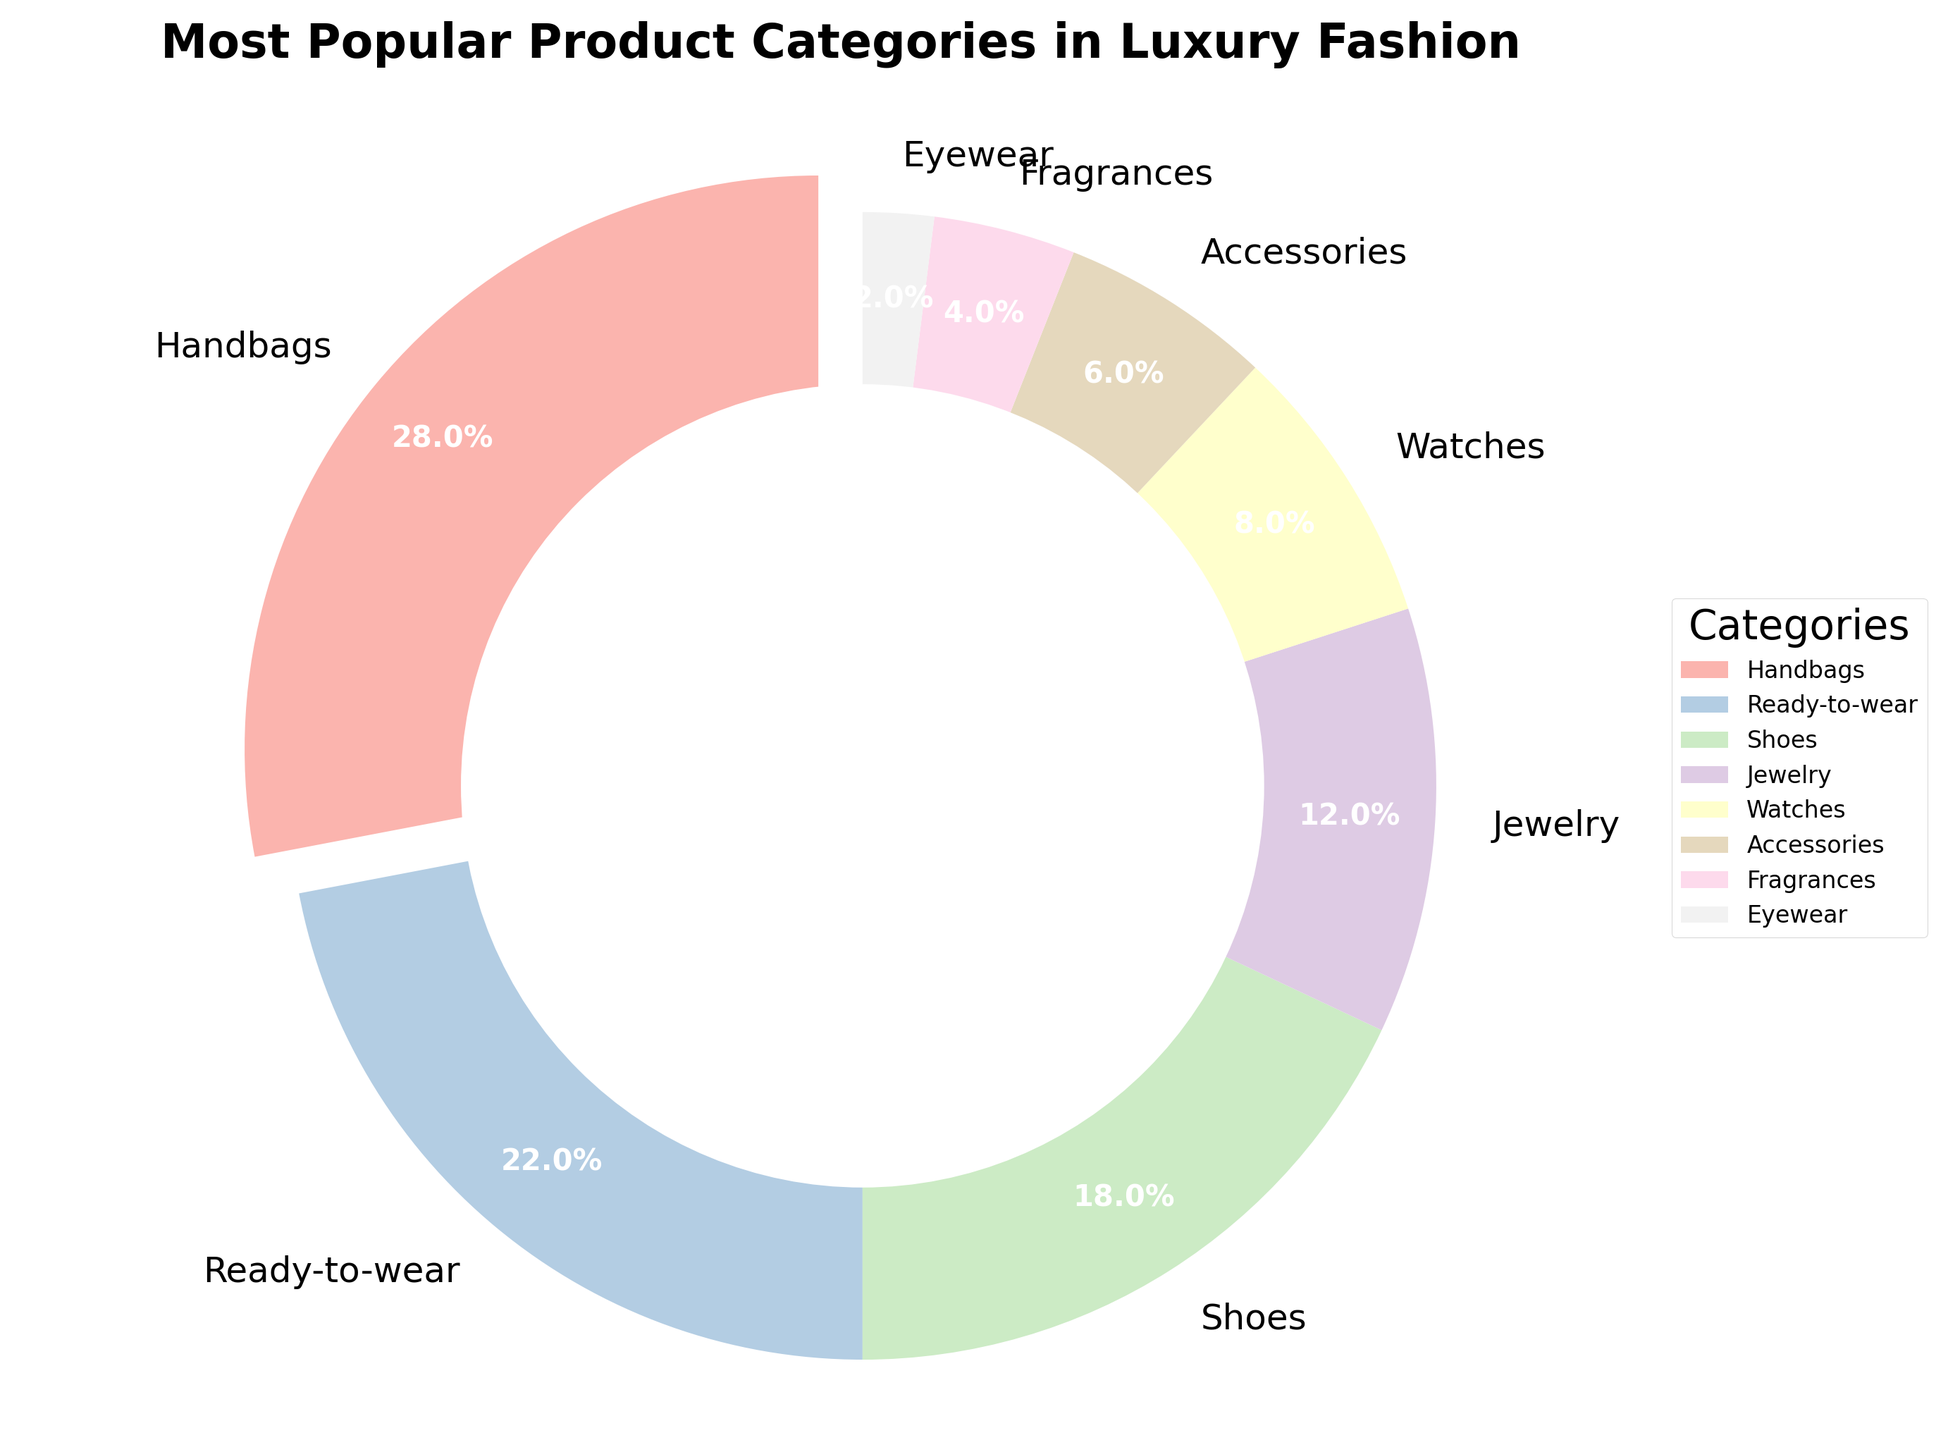What is the most popular product category in the luxury fashion industry according to the pie chart? The slice of the pie chart with the largest value is "Handbags", indicated by both its size and a 28% label.
Answer: Handbags Which product category has the smallest share in the luxury fashion market? The smallest slice in the pie chart is labeled "Eyewear" with a percentage of 2%.
Answer: Eyewear What is the combined market share of "Jewelry" and "Watches"? By looking at the pie chart, the percentages for Jewelry and Watches are 12% and 8%, respectively. Adding these gives 12% + 8% = 20%.
Answer: 20% Which product category is second most popular after Handbags? The second largest slice after Handbags (28%) is labeled Ready-to-wear with a percentage of 22%.
Answer: Ready-to-wear How much more popular are Shoes compared to Accessories? The pie chart shows Shoes with 18% and Accessories with 6%. The difference is calculated as 18% - 6% = 12%.
Answer: 12% What is the color of the slice representing Fragrances? According to the color scheme used in the pie chart, Fragrances are represented by a specific pastel color. Since pastel colors vary, refer to the visual provided, which indicates Fragrances are in a pastel shade.
Answer: Pastel color (specific shade should be visually observed) How much more market share do the top three categories hold compared to the bottom three categories? The top three categories are Handbags (28%), Ready-to-wear (22%), and Shoes (18%), which sum to 28% + 22% + 18% = 68%. The bottom three categories are Eyewear (2%), Fragrances (4%), and Accessories (6%), summing to 2% + 4% + 6% = 12%. The difference is 68% - 12% = 56%.
Answer: 56% Which categories together comprise less than 10% of the market? From the pie chart, Eyewear (2%) and Fragrances (4%) each contribute less than 10% individually but together sum to 2% + 4% = 6%, which is still less than 10%.
Answer: Eyewear and Fragrances What is the average percentage share of the "Ready-to-wear", "Shoes", and "Jewelry" categories? Summing the percentages for Ready-to-wear (22%), Shoes (18%), and Jewelry (12%) results in 22% + 18% + 12% = 52%. The average is calculated as 52% / 3 = 17.33%.
Answer: 17.33% Is the share of Watches more than double the share of Eyewear? Watches have an 8% share while Eyewear has a 2% share. Doubling Eyewear’s share is 2% * 2 = 4%, and since 8% (Watches) is greater than 4%, the answer is yes.
Answer: Yes 